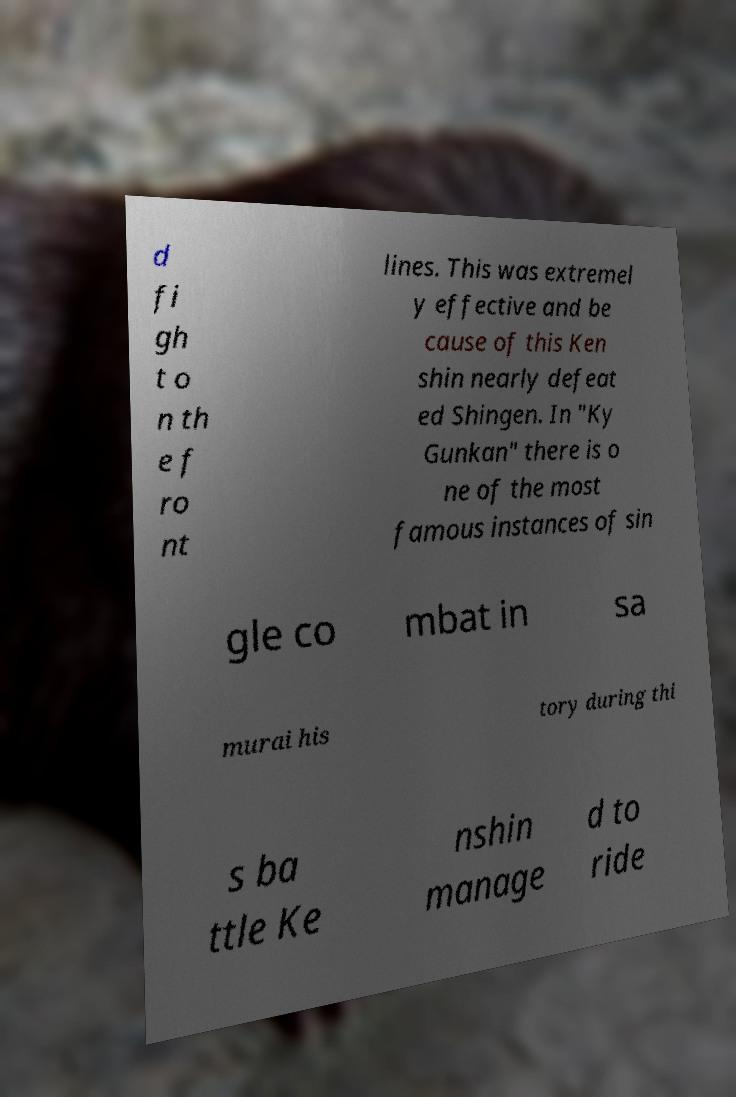Please read and relay the text visible in this image. What does it say? d fi gh t o n th e f ro nt lines. This was extremel y effective and be cause of this Ken shin nearly defeat ed Shingen. In "Ky Gunkan" there is o ne of the most famous instances of sin gle co mbat in sa murai his tory during thi s ba ttle Ke nshin manage d to ride 